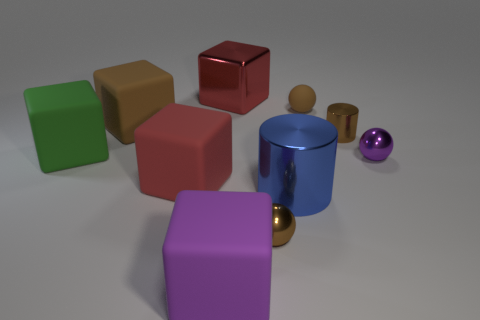Is the large red rubber thing the same shape as the tiny rubber object?
Make the answer very short. No. Is there a purple cube made of the same material as the tiny brown cylinder?
Provide a succinct answer. No. There is a metallic object that is both behind the tiny purple metallic thing and on the right side of the big blue cylinder; what color is it?
Your answer should be compact. Brown. What material is the big red thing behind the tiny shiny cylinder?
Offer a very short reply. Metal. Are there any red shiny objects of the same shape as the big brown thing?
Give a very brief answer. Yes. What number of other objects are there of the same shape as the small purple metal thing?
Give a very brief answer. 2. There is a green rubber thing; does it have the same shape as the tiny brown shiny object on the left side of the blue metallic cylinder?
Give a very brief answer. No. Is there anything else that is the same material as the small brown cylinder?
Make the answer very short. Yes. There is a green object that is the same shape as the big brown rubber object; what is its material?
Your answer should be compact. Rubber. What number of big things are either blue things or blocks?
Give a very brief answer. 6. 